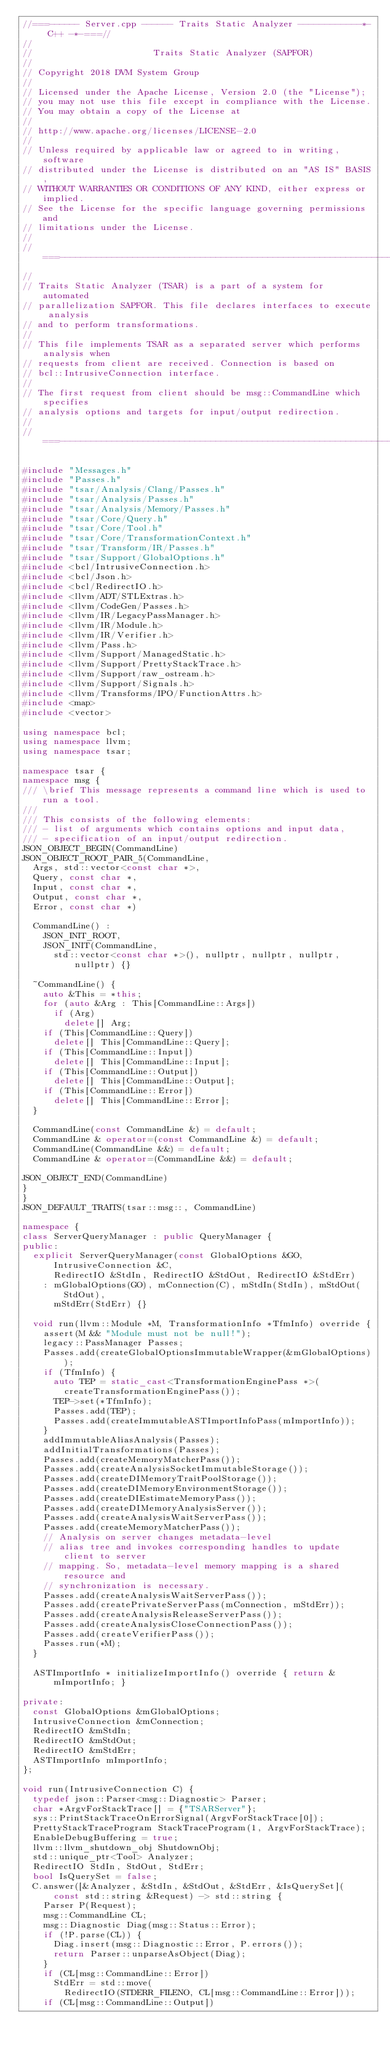Convert code to text. <code><loc_0><loc_0><loc_500><loc_500><_C++_>//===------ Server.cpp ------ Traits Static Analyzer ------------*- C++ -*-===//
//
//                       Traits Static Analyzer (SAPFOR)
//
// Copyright 2018 DVM System Group
//
// Licensed under the Apache License, Version 2.0 (the "License");
// you may not use this file except in compliance with the License.
// You may obtain a copy of the License at
//
// http://www.apache.org/licenses/LICENSE-2.0
//
// Unless required by applicable law or agreed to in writing, software
// distributed under the License is distributed on an "AS IS" BASIS,
// WITHOUT WARRANTIES OR CONDITIONS OF ANY KIND, either express or implied.
// See the License for the specific language governing permissions and
// limitations under the License.
//
//===----------------------------------------------------------------------===//
//
// Traits Static Analyzer (TSAR) is a part of a system for automated
// parallelization SAPFOR. This file declares interfaces to execute analysis
// and to perform transformations.
//
// This file implements TSAR as a separated server which performs analysis when
// requests from client are received. Connection is based on
// bcl::IntrusiveConnection interface.
//
// The first request from client should be msg::CommandLine which specifies
// analysis options and targets for input/output redirection.
//
//===----------------------------------------------------------------------===//

#include "Messages.h"
#include "Passes.h"
#include "tsar/Analysis/Clang/Passes.h"
#include "tsar/Analysis/Passes.h"
#include "tsar/Analysis/Memory/Passes.h"
#include "tsar/Core/Query.h"
#include "tsar/Core/Tool.h"
#include "tsar/Core/TransformationContext.h"
#include "tsar/Transform/IR/Passes.h"
#include "tsar/Support/GlobalOptions.h"
#include <bcl/IntrusiveConnection.h>
#include <bcl/Json.h>
#include <bcl/RedirectIO.h>
#include <llvm/ADT/STLExtras.h>
#include <llvm/CodeGen/Passes.h>
#include <llvm/IR/LegacyPassManager.h>
#include <llvm/IR/Module.h>
#include <llvm/IR/Verifier.h>
#include <llvm/Pass.h>
#include <llvm/Support/ManagedStatic.h>
#include <llvm/Support/PrettyStackTrace.h>
#include <llvm/Support/raw_ostream.h>
#include <llvm/Support/Signals.h>
#include <llvm/Transforms/IPO/FunctionAttrs.h>
#include <map>
#include <vector>

using namespace bcl;
using namespace llvm;
using namespace tsar;

namespace tsar {
namespace msg {
/// \brief This message represents a command line which is used to run a tool.
///
/// This consists of the following elements:
/// - list of arguments which contains options and input data,
/// - specification of an input/output redirection.
JSON_OBJECT_BEGIN(CommandLine)
JSON_OBJECT_ROOT_PAIR_5(CommandLine,
  Args, std::vector<const char *>,
  Query, const char *,
  Input, const char *,
  Output, const char *,
  Error, const char *)

  CommandLine() :
    JSON_INIT_ROOT,
    JSON_INIT(CommandLine,
      std::vector<const char *>(), nullptr, nullptr, nullptr, nullptr) {}

  ~CommandLine() {
    auto &This = *this;
    for (auto &Arg : This[CommandLine::Args])
      if (Arg)
        delete[] Arg;
    if (This[CommandLine::Query])
      delete[] This[CommandLine::Query];
    if (This[CommandLine::Input])
      delete[] This[CommandLine::Input];
    if (This[CommandLine::Output])
      delete[] This[CommandLine::Output];
    if (This[CommandLine::Error])
      delete[] This[CommandLine::Error];
  }

  CommandLine(const CommandLine &) = default;
  CommandLine & operator=(const CommandLine &) = default;
  CommandLine(CommandLine &&) = default;
  CommandLine & operator=(CommandLine &&) = default;

JSON_OBJECT_END(CommandLine)
}
}
JSON_DEFAULT_TRAITS(tsar::msg::, CommandLine)

namespace {
class ServerQueryManager : public QueryManager {
public:
  explicit ServerQueryManager(const GlobalOptions &GO, IntrusiveConnection &C,
      RedirectIO &StdIn, RedirectIO &StdOut, RedirectIO &StdErr)
    : mGlobalOptions(GO), mConnection(C), mStdIn(StdIn), mStdOut(StdOut),
      mStdErr(StdErr) {}

  void run(llvm::Module *M, TransformationInfo *TfmInfo) override {
    assert(M && "Module must not be null!");
    legacy::PassManager Passes;
    Passes.add(createGlobalOptionsImmutableWrapper(&mGlobalOptions));
    if (TfmInfo) {
      auto TEP = static_cast<TransformationEnginePass *>(
        createTransformationEnginePass());
      TEP->set(*TfmInfo);
      Passes.add(TEP);
      Passes.add(createImmutableASTImportInfoPass(mImportInfo));
    }
    addImmutableAliasAnalysis(Passes);
    addInitialTransformations(Passes);
    Passes.add(createMemoryMatcherPass());
    Passes.add(createAnalysisSocketImmutableStorage());
    Passes.add(createDIMemoryTraitPoolStorage());
    Passes.add(createDIMemoryEnvironmentStorage());
    Passes.add(createDIEstimateMemoryPass());
    Passes.add(createDIMemoryAnalysisServer());
    Passes.add(createAnalysisWaitServerPass());
    Passes.add(createMemoryMatcherPass());
    // Analysis on server changes metadata-level
    // alias tree and invokes corresponding handles to update client to server
    // mapping. So, metadata-level memory mapping is a shared resource and
    // synchronization is necessary.
    Passes.add(createAnalysisWaitServerPass());
    Passes.add(createPrivateServerPass(mConnection, mStdErr));
    Passes.add(createAnalysisReleaseServerPass());
    Passes.add(createAnalysisCloseConnectionPass());
    Passes.add(createVerifierPass());
    Passes.run(*M);
  }

  ASTImportInfo * initializeImportInfo() override { return &mImportInfo; }

private:
  const GlobalOptions &mGlobalOptions;
  IntrusiveConnection &mConnection;
  RedirectIO &mStdIn;
  RedirectIO &mStdOut;
  RedirectIO &mStdErr;
  ASTImportInfo mImportInfo;
};

void run(IntrusiveConnection C) {
  typedef json::Parser<msg::Diagnostic> Parser;
  char *ArgvForStackTrace[] = {"TSARServer"};
  sys::PrintStackTraceOnErrorSignal(ArgvForStackTrace[0]);
  PrettyStackTraceProgram StackTraceProgram(1, ArgvForStackTrace);
  EnableDebugBuffering = true;
  llvm::llvm_shutdown_obj ShutdownObj;
  std::unique_ptr<Tool> Analyzer;
  RedirectIO StdIn, StdOut, StdErr;
  bool IsQuerySet = false;
  C.answer([&Analyzer, &StdIn, &StdOut, &StdErr, &IsQuerySet](
      const std::string &Request) -> std::string {
    Parser P(Request);
    msg::CommandLine CL;
    msg::Diagnostic Diag(msg::Status::Error);
    if (!P.parse(CL)) {
      Diag.insert(msg::Diagnostic::Error, P.errors());
      return Parser::unparseAsObject(Diag);
    }
    if (CL[msg::CommandLine::Error])
      StdErr = std::move(
        RedirectIO(STDERR_FILENO, CL[msg::CommandLine::Error]));
    if (CL[msg::CommandLine::Output])</code> 